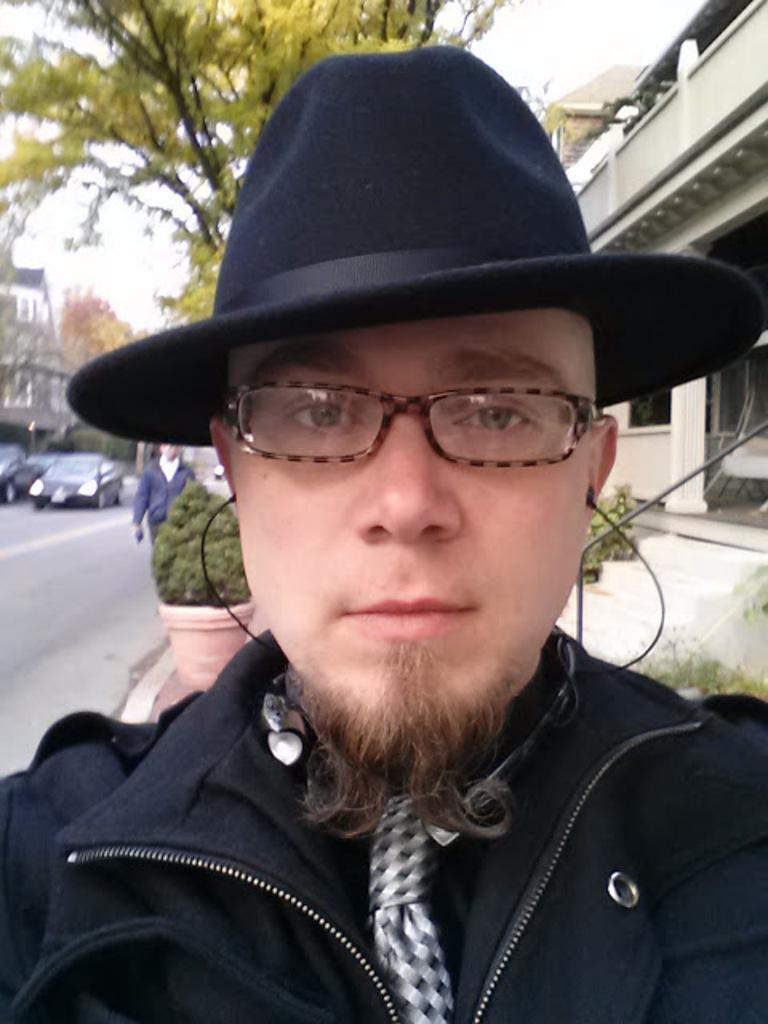In one or two sentences, can you explain what this image depicts? In this image we can see one man with black hat, wearing earphones, some buildings, one chair, some plants, some bushes, some trees, one plant in the pot, one man walking on the road and holding one object. At the top there is the sky. 